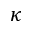Convert formula to latex. <formula><loc_0><loc_0><loc_500><loc_500>\kappa</formula> 